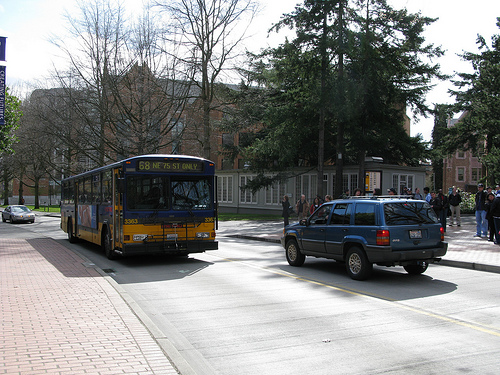Can you tell me what kind of vehicles are present in this scene? Aside from the prominent public transit bus, there is also a blue SUV driving on the road next to the bus. 